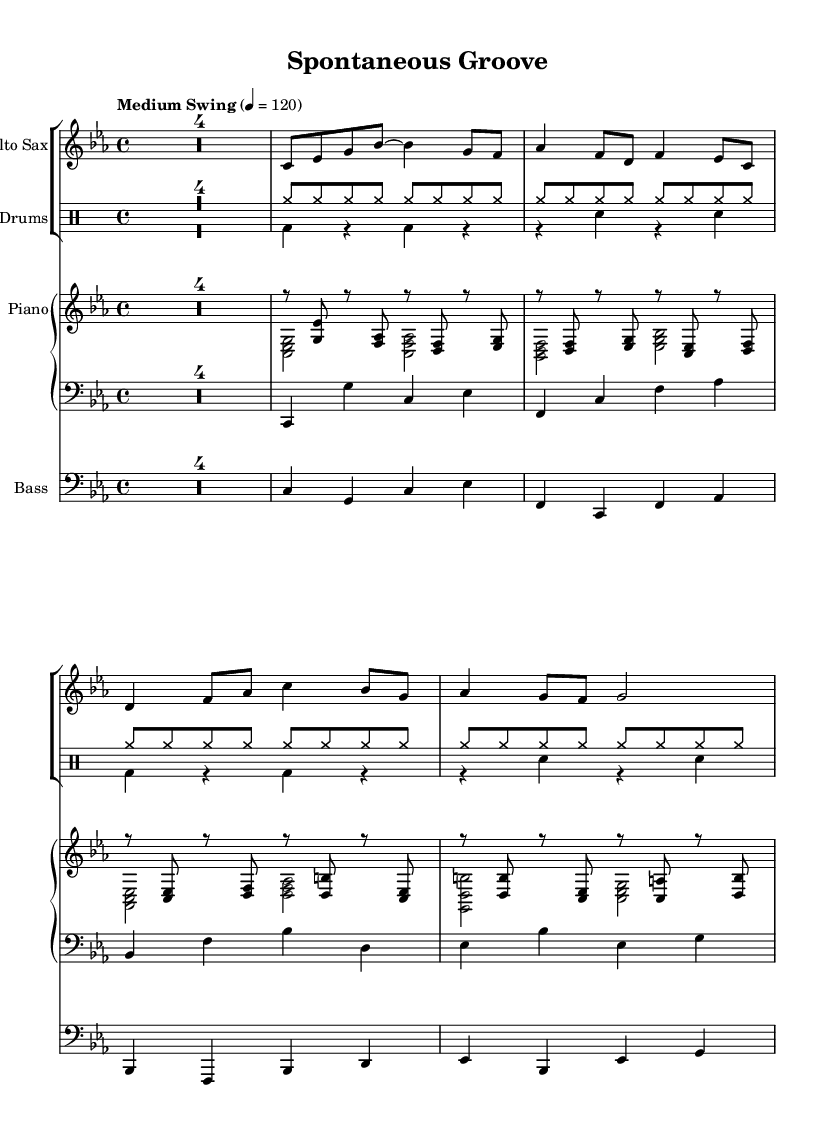What is the key signature of this music? The key signature is C minor, indicated by three flats in the key signature on the left side of the staff.
Answer: C minor What is the time signature of this piece? The time signature is indicated as 4/4, meaning there are four beats in each measure and a quarter note receives one beat. This is shown at the beginning of the music.
Answer: 4/4 What is the tempo marking for this performance? The tempo marking is indicated as "Medium Swing," with a metronome marking of 120 beats per minute, found above the staff at the beginning.
Answer: Medium Swing How many measures does the saxophone part have in total? By counting each measure in the saxophone staff, which is notated with vertical lines, we find there are a total of 8 measures.
Answer: 8 Which instruments are included in this score? The score includes an alto sax, piano (with separate right and left hands), bass, and drums, as listed in the staff names and the format of the score.
Answer: Alto Sax, Piano, Bass, Drums Which note does the saxophone start with? The saxophone part begins with a C note, located on the first defined pitch of the measure at the start of the saxophone staff.
Answer: C What unique jazz element is reflected in the drum notation? The unique element is the use of syncopation, indicated by the rhythmic pattern throughout the drum section that emphasizes off-beats, showcasing a typical characteristic of jazz improv.
Answer: Syncopation 